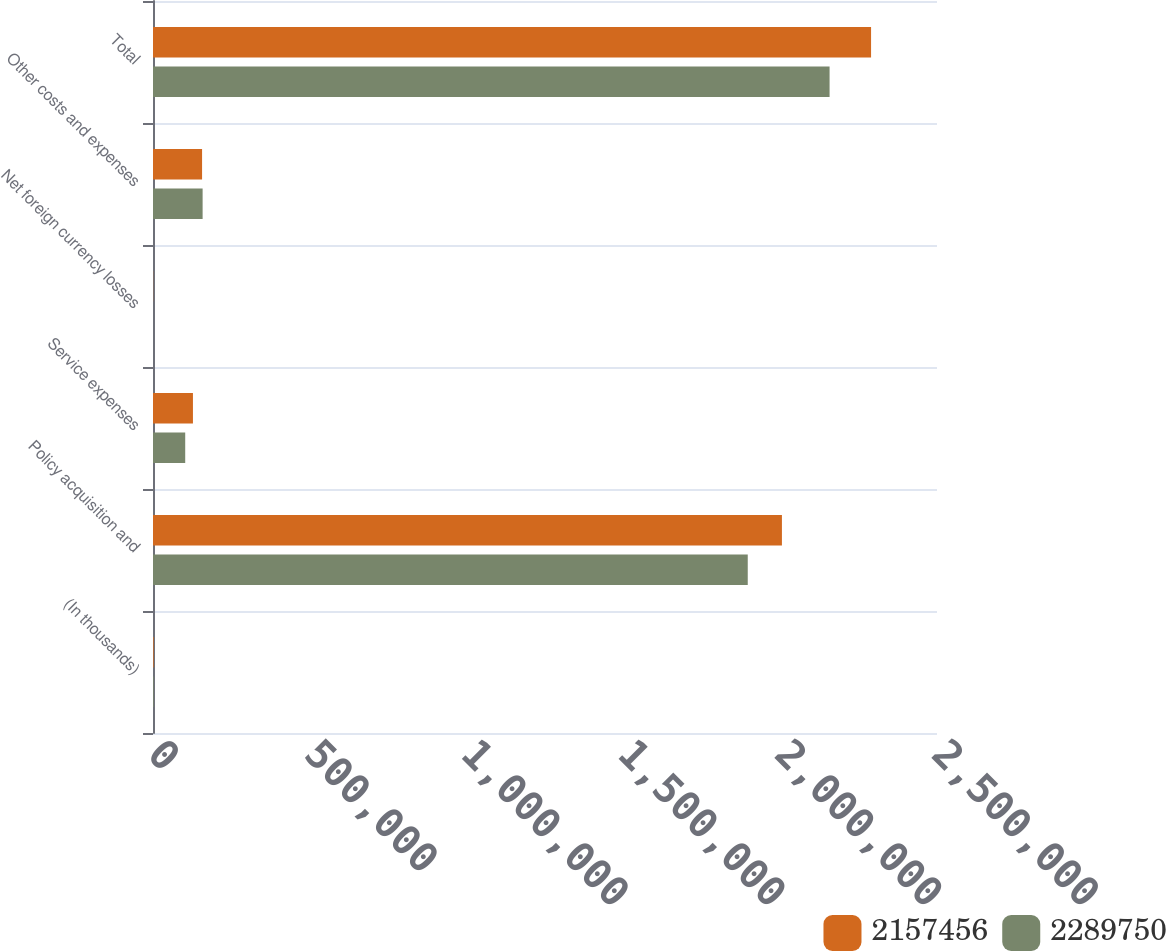Convert chart. <chart><loc_0><loc_0><loc_500><loc_500><stacked_bar_chart><ecel><fcel>(In thousands)<fcel>Policy acquisition and<fcel>Service expenses<fcel>Net foreign currency losses<fcel>Other costs and expenses<fcel>Total<nl><fcel>2.15746e+06<fcel>2015<fcel>2.0055e+06<fcel>127365<fcel>400<fcel>156487<fcel>2.28975e+06<nl><fcel>2.28975e+06<fcel>2014<fcel>1.89653e+06<fcel>102726<fcel>27<fcel>158227<fcel>2.15746e+06<nl></chart> 